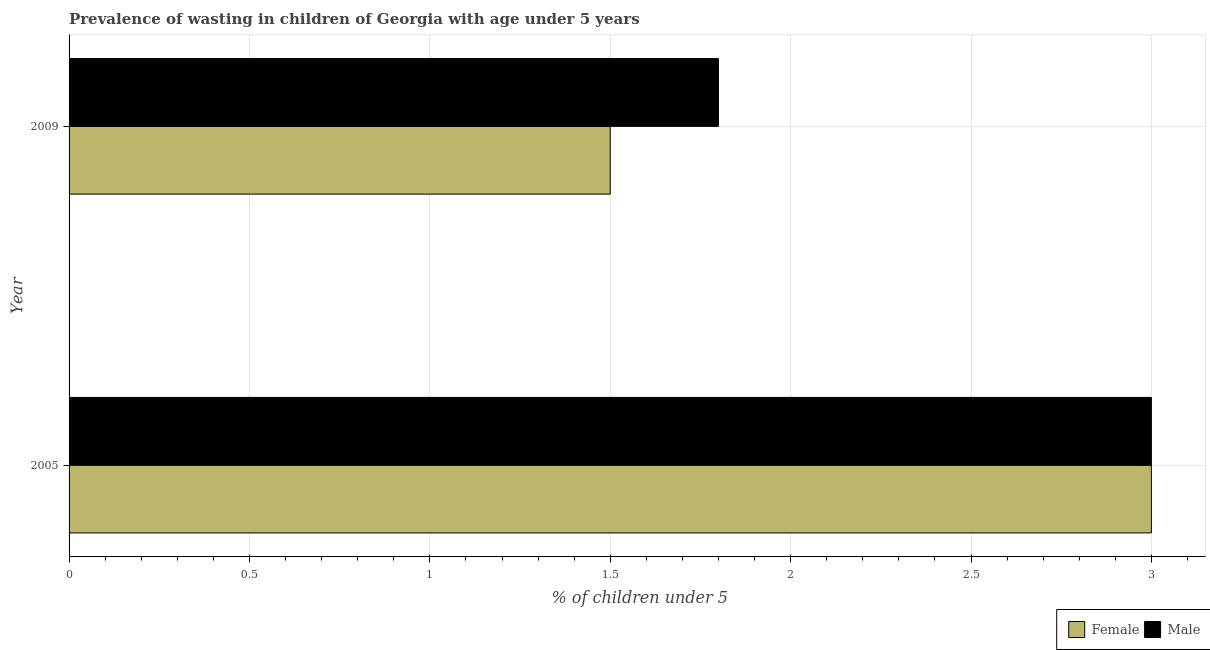Are the number of bars on each tick of the Y-axis equal?
Keep it short and to the point. Yes. What is the label of the 1st group of bars from the top?
Your response must be concise. 2009. Across all years, what is the maximum percentage of undernourished male children?
Offer a very short reply. 3. Across all years, what is the minimum percentage of undernourished female children?
Keep it short and to the point. 1.5. In which year was the percentage of undernourished female children maximum?
Ensure brevity in your answer.  2005. In which year was the percentage of undernourished male children minimum?
Provide a short and direct response. 2009. What is the total percentage of undernourished male children in the graph?
Provide a short and direct response. 4.8. What is the difference between the percentage of undernourished male children in 2005 and that in 2009?
Your answer should be very brief. 1.2. What is the difference between the percentage of undernourished female children in 2009 and the percentage of undernourished male children in 2005?
Make the answer very short. -1.5. What is the average percentage of undernourished male children per year?
Make the answer very short. 2.4. In how many years, is the percentage of undernourished male children greater than 0.7 %?
Offer a terse response. 2. What is the ratio of the percentage of undernourished male children in 2005 to that in 2009?
Make the answer very short. 1.67. Is the difference between the percentage of undernourished male children in 2005 and 2009 greater than the difference between the percentage of undernourished female children in 2005 and 2009?
Offer a terse response. No. In how many years, is the percentage of undernourished male children greater than the average percentage of undernourished male children taken over all years?
Offer a very short reply. 1. What does the 2nd bar from the bottom in 2005 represents?
Ensure brevity in your answer.  Male. Are all the bars in the graph horizontal?
Provide a short and direct response. Yes. Are the values on the major ticks of X-axis written in scientific E-notation?
Give a very brief answer. No. Where does the legend appear in the graph?
Your response must be concise. Bottom right. How many legend labels are there?
Your answer should be very brief. 2. How are the legend labels stacked?
Provide a short and direct response. Horizontal. What is the title of the graph?
Offer a very short reply. Prevalence of wasting in children of Georgia with age under 5 years. What is the label or title of the X-axis?
Your answer should be compact.  % of children under 5. What is the  % of children under 5 in Male in 2005?
Your response must be concise. 3. What is the  % of children under 5 in Female in 2009?
Your answer should be compact. 1.5. What is the  % of children under 5 in Male in 2009?
Provide a succinct answer. 1.8. Across all years, what is the maximum  % of children under 5 of Male?
Provide a succinct answer. 3. Across all years, what is the minimum  % of children under 5 in Female?
Ensure brevity in your answer.  1.5. Across all years, what is the minimum  % of children under 5 of Male?
Your response must be concise. 1.8. What is the total  % of children under 5 in Female in the graph?
Provide a short and direct response. 4.5. What is the total  % of children under 5 of Male in the graph?
Provide a short and direct response. 4.8. What is the difference between the  % of children under 5 of Male in 2005 and that in 2009?
Your answer should be very brief. 1.2. What is the difference between the  % of children under 5 in Female in 2005 and the  % of children under 5 in Male in 2009?
Ensure brevity in your answer.  1.2. What is the average  % of children under 5 in Female per year?
Keep it short and to the point. 2.25. What is the average  % of children under 5 of Male per year?
Ensure brevity in your answer.  2.4. What is the ratio of the  % of children under 5 in Female in 2005 to that in 2009?
Provide a short and direct response. 2. What is the difference between the highest and the second highest  % of children under 5 in Female?
Your answer should be compact. 1.5. What is the difference between the highest and the second highest  % of children under 5 in Male?
Your answer should be compact. 1.2. What is the difference between the highest and the lowest  % of children under 5 in Female?
Keep it short and to the point. 1.5. What is the difference between the highest and the lowest  % of children under 5 of Male?
Give a very brief answer. 1.2. 